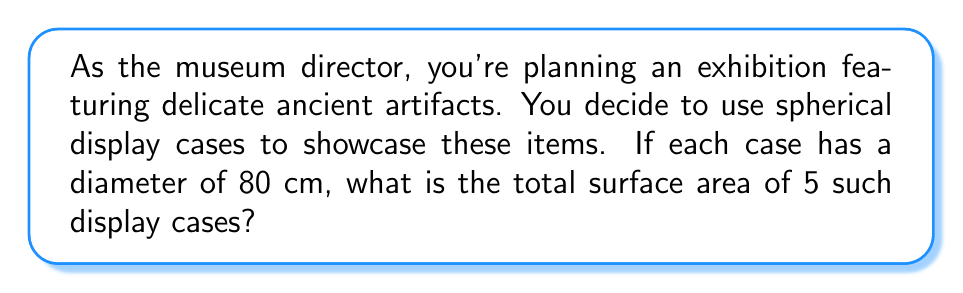Could you help me with this problem? Let's approach this step-by-step:

1) The formula for the surface area of a sphere is:

   $$A = 4\pi r^2$$

   where $A$ is the surface area and $r$ is the radius.

2) We're given the diameter, which is 80 cm. The radius is half of this:

   $$r = \frac{80}{2} = 40 \text{ cm}$$

3) Now we can substitute this into our formula:

   $$A = 4\pi (40)^2$$

4) Simplify:

   $$A = 4\pi (1600) = 6400\pi \text{ cm}^2$$

5) We can leave our answer in terms of $\pi$, or we can calculate an approximate value:

   $$A \approx 6400 \times 3.14159 \approx 20106.18 \text{ cm}^2$$

6) This is the surface area for one display case. The question asks for the total surface area of 5 cases, so we multiply by 5:

   $$5A = 5(6400\pi) = 32000\pi \text{ cm}^2$$

   Or approximately:

   $$5A \approx 5(20106.18) \approx 100530.9 \text{ cm}^2$$
Answer: $32000\pi \text{ cm}^2$ or approximately $100530.9 \text{ cm}^2$ 